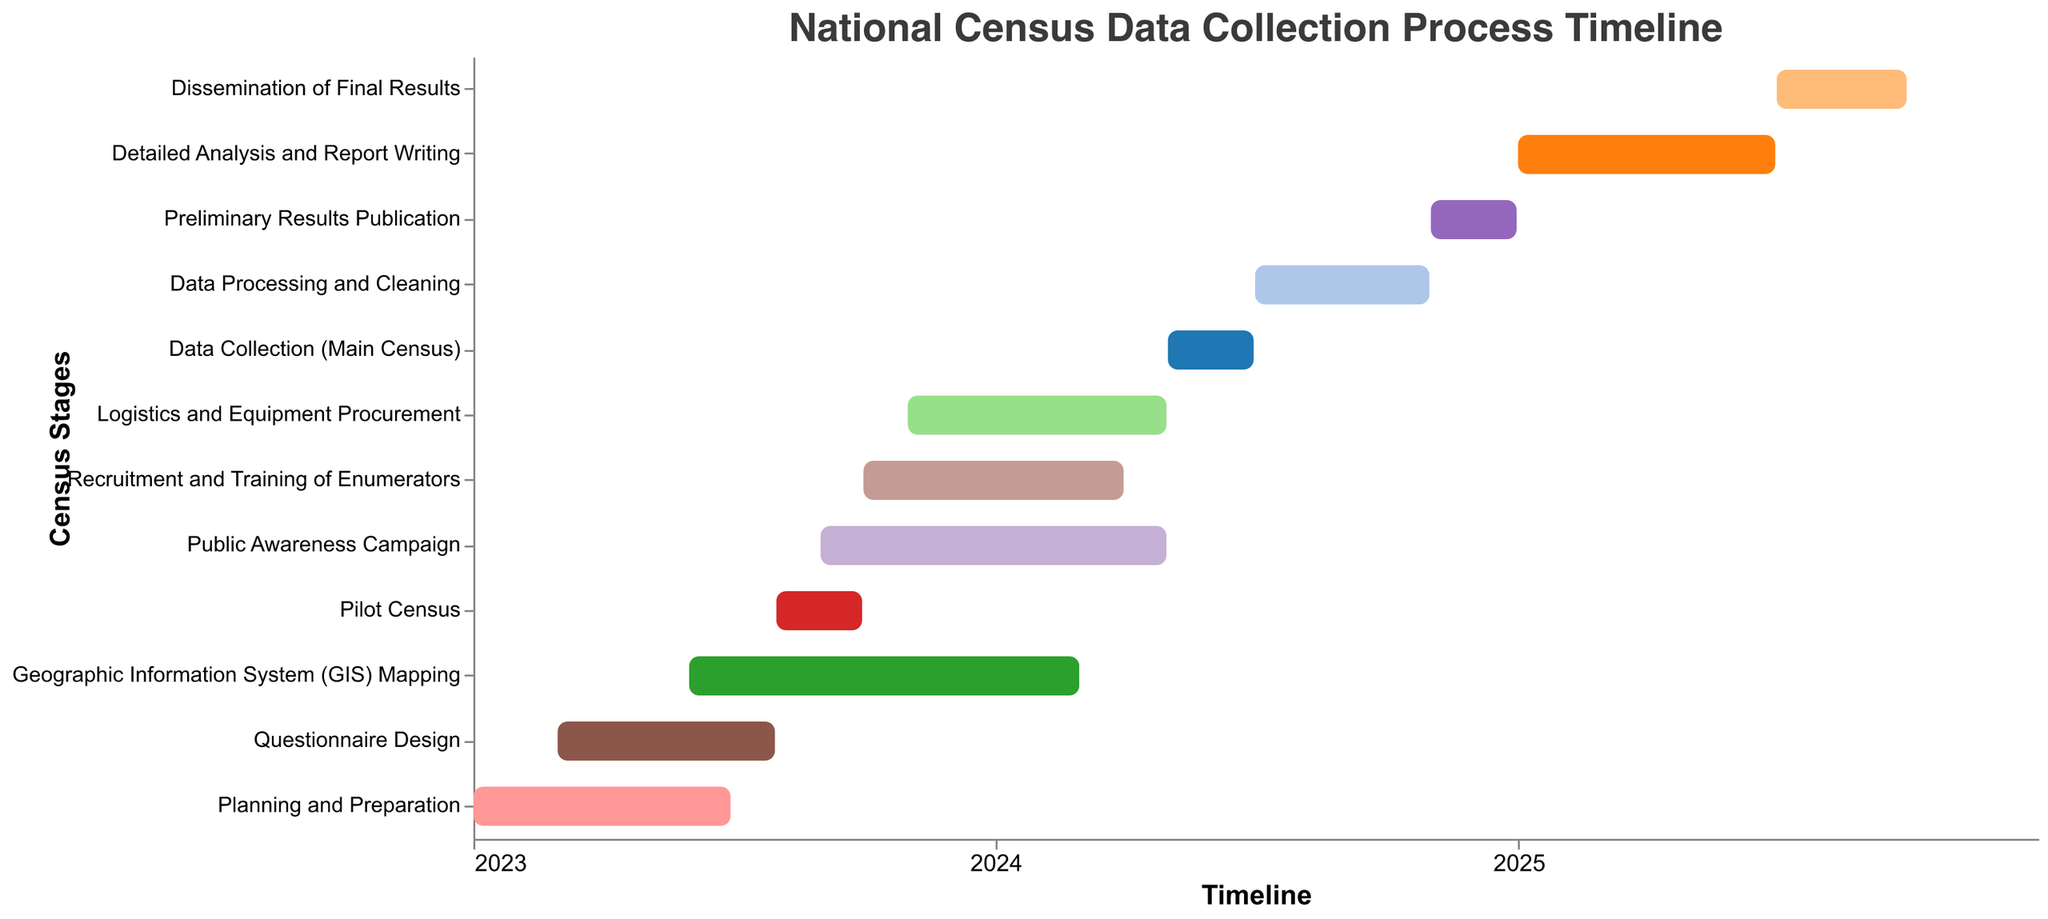What is the title of the Gantt chart? The title is positioned at the top of the chart and clearly indicates the overall subject matter being visualized.
Answer: National Census Data Collection Process Timeline How long does the "Questionnaire Design" stage last? First, identify the start and end dates for "Questionnaire Design". Subtract the start date from the end date to find the duration. Start: March 1, 2023. End: July 31, 2023. Duration calculation: 31 days (March) + 30 days (April) + 31 days (May) + 30 days (June) + 31 days (July).
Answer: Approximately 5 months Which stage has the longest duration? Compare the durations of all stages by calculating the difference between the start and end dates for each.
Answer: Dissemination of Final Results During which months does the "Public Awareness Campaign" happen? Look at the start and end dates for the "Public Awareness Campaign" and list the months covered by this period.
Answer: September 2023 to April 2024 When does the "Data Collection (Main Census)" stage occur? Identify the start and end dates for the "Data Collection (Main Census)" on the chart.
Answer: May 1, 2024, to June 30, 2024 Which tasks are occurring simultaneously in June 2024? Identify tasks whose timelines intersect with June 2024 by comparing their start and end dates.
Answer: Public Awareness Campaign, Recruitment and Training of Enumerators, Logistics and Equipment Procurement, Data Collection (Main Census) How does the duration of "Data Processing and Cleaning" compare to "Detailed Analysis and Report Writing"? Calculate the duration for both stages and compare them. "Data Processing and Cleaning": July 1, 2024, to October 31, 2024 (4 months). "Detailed Analysis and Report Writing": January 1, 2025, to June 30, 2025 (6 months).
Answer: Detailed Analysis and Report Writing is longer Which stage comes directly after "Data Collection (Main Census)"? Identify the task that has its start date immediately following the end date of "Data Collection (Main Census)".
Answer: Data Processing and Cleaning How many stages overlap with "Recruitment and Training of Enumerators"? Identify all stages that have any date range that overlaps with October 1, 2023 to March 31, 2024.
Answer: Four (Public Awareness Campaign, Geographic Information System (GIS) Mapping, Logistics and Equipment Procurement, Public Awareness Campaign again) What is the total number of stages involved in the census data collection process? Count the number of unique tasks in the chart by observing the Y-axis labels.
Answer: 12 